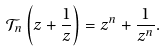<formula> <loc_0><loc_0><loc_500><loc_500>\mathcal { T } _ { n } \left ( z + \frac { 1 } { z } \right ) = z ^ { n } + \frac { 1 } { z ^ { n } } .</formula> 